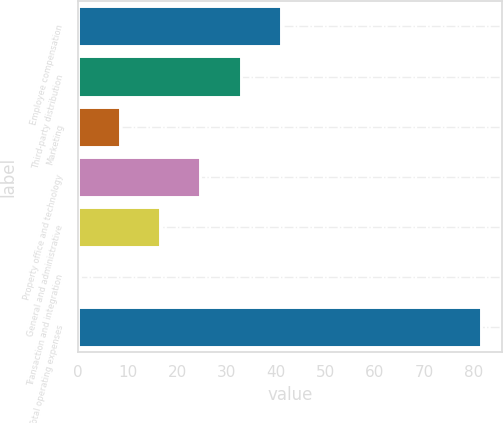Convert chart to OTSL. <chart><loc_0><loc_0><loc_500><loc_500><bar_chart><fcel>Employee compensation<fcel>Third-party distribution<fcel>Marketing<fcel>Property office and technology<fcel>General and administrative<fcel>Transaction and integration<fcel>Total operating expenses<nl><fcel>40.95<fcel>32.84<fcel>8.51<fcel>24.73<fcel>16.62<fcel>0.4<fcel>81.5<nl></chart> 